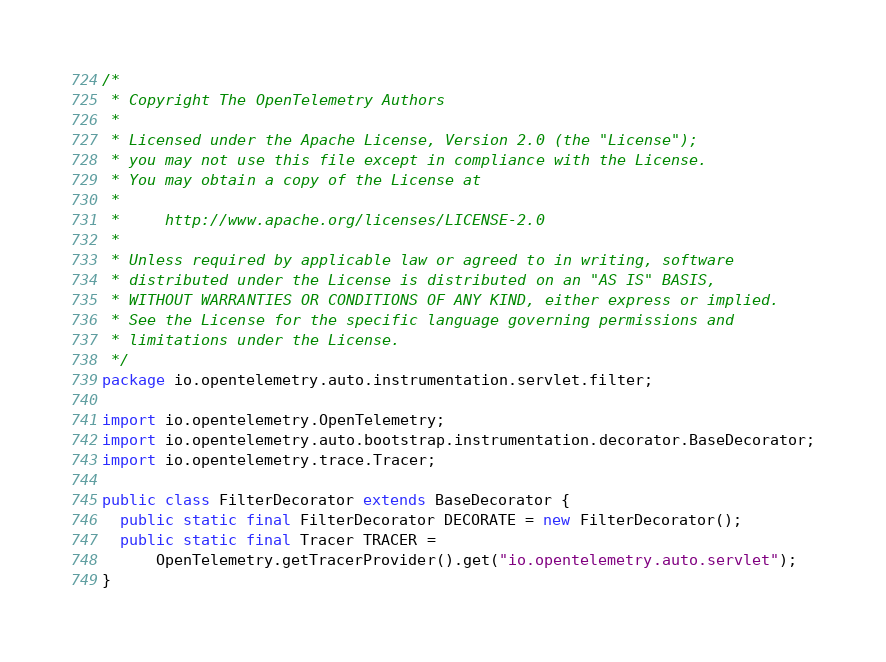<code> <loc_0><loc_0><loc_500><loc_500><_Java_>/*
 * Copyright The OpenTelemetry Authors
 *
 * Licensed under the Apache License, Version 2.0 (the "License");
 * you may not use this file except in compliance with the License.
 * You may obtain a copy of the License at
 *
 *     http://www.apache.org/licenses/LICENSE-2.0
 *
 * Unless required by applicable law or agreed to in writing, software
 * distributed under the License is distributed on an "AS IS" BASIS,
 * WITHOUT WARRANTIES OR CONDITIONS OF ANY KIND, either express or implied.
 * See the License for the specific language governing permissions and
 * limitations under the License.
 */
package io.opentelemetry.auto.instrumentation.servlet.filter;

import io.opentelemetry.OpenTelemetry;
import io.opentelemetry.auto.bootstrap.instrumentation.decorator.BaseDecorator;
import io.opentelemetry.trace.Tracer;

public class FilterDecorator extends BaseDecorator {
  public static final FilterDecorator DECORATE = new FilterDecorator();
  public static final Tracer TRACER =
      OpenTelemetry.getTracerProvider().get("io.opentelemetry.auto.servlet");
}
</code> 